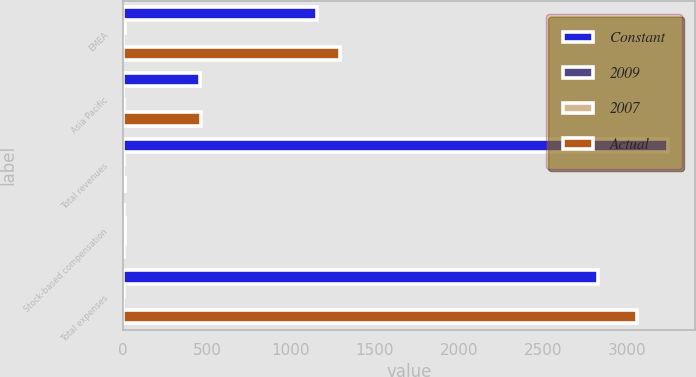Convert chart to OTSL. <chart><loc_0><loc_0><loc_500><loc_500><stacked_bar_chart><ecel><fcel>EMEA<fcel>Asia Pacific<fcel>Total revenues<fcel>Stock-based compensation<fcel>Total expenses<nl><fcel>Constant<fcel>1152<fcel>456<fcel>3247<fcel>6<fcel>2827<nl><fcel>2009<fcel>11<fcel>2<fcel>7<fcel>12<fcel>8<nl><fcel>2007<fcel>1<fcel>5<fcel>1<fcel>12<fcel>2<nl><fcel>Actual<fcel>1291<fcel>466<fcel>11<fcel>7<fcel>3063<nl></chart> 